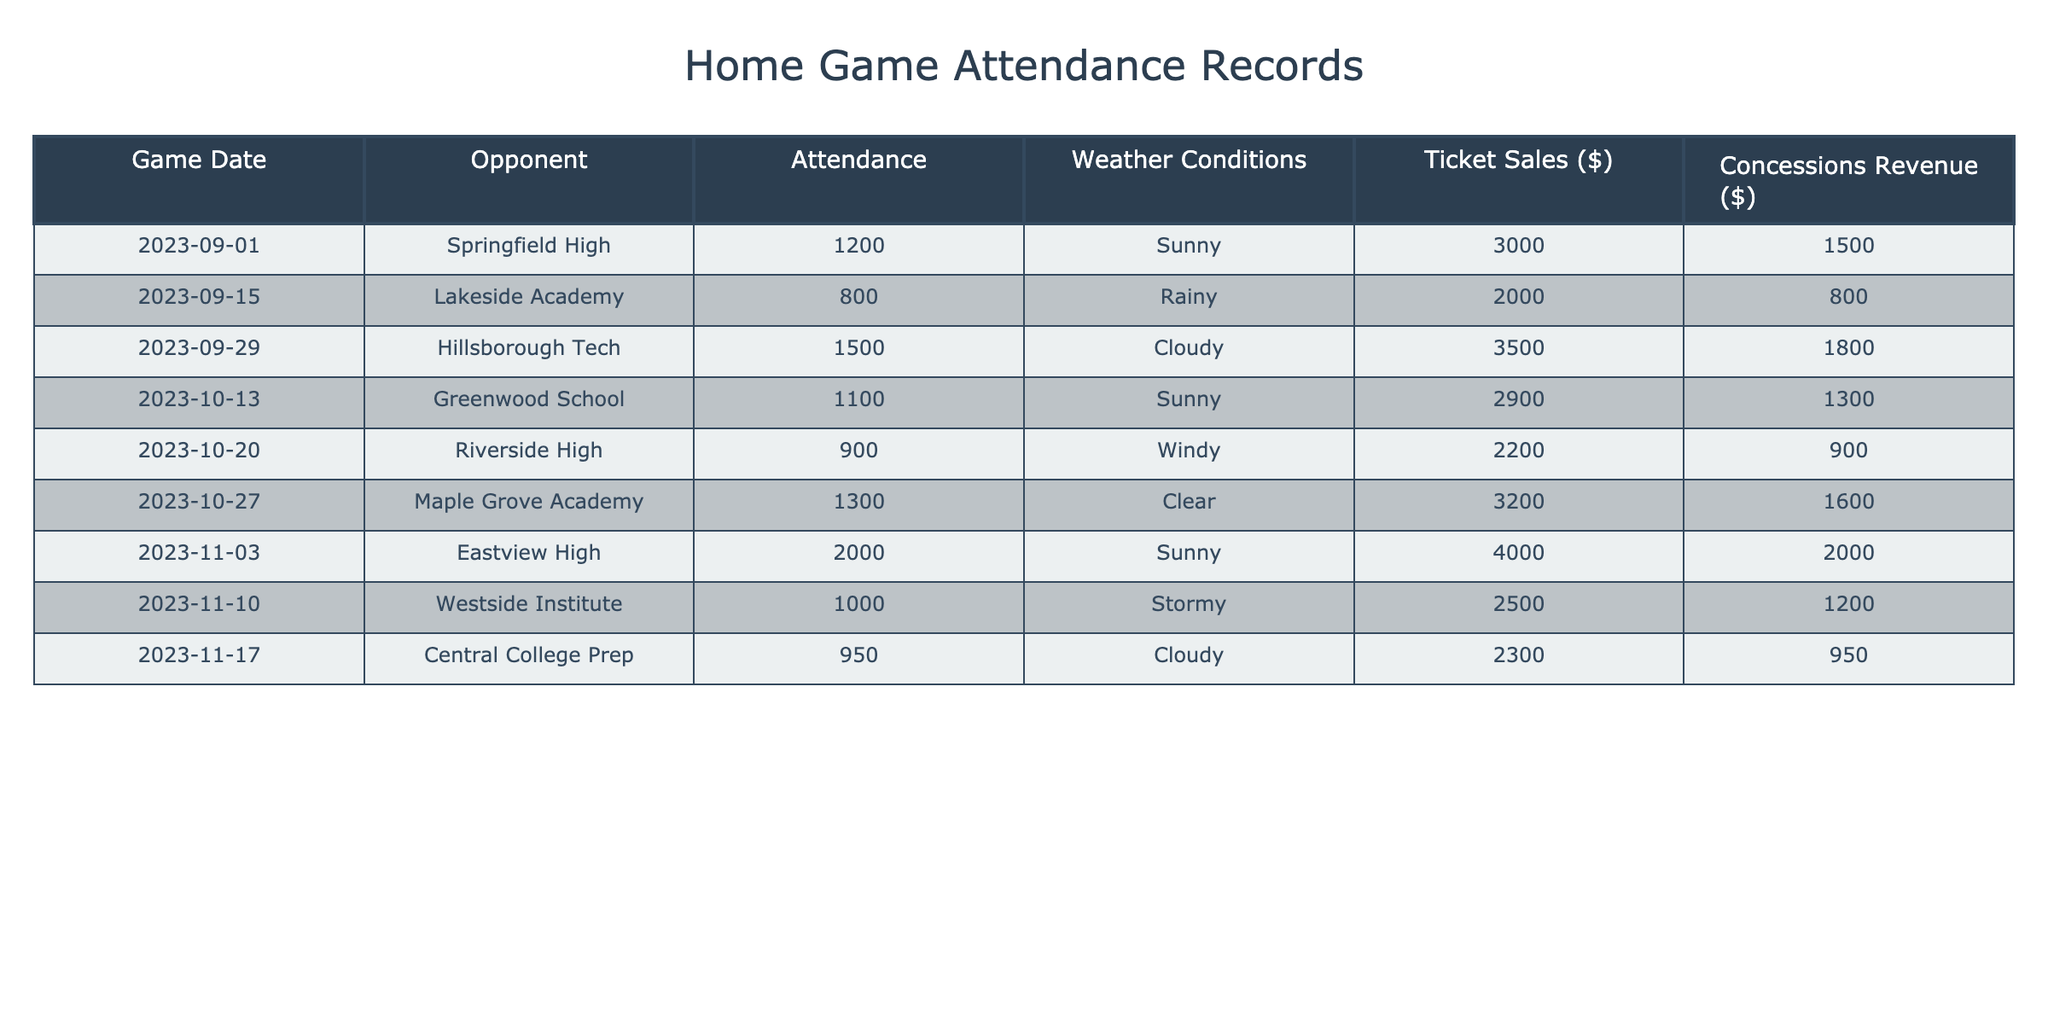What was the attendance for the game against Eastview High? The attendance for the game against Eastview High on November 3, 2023, is listed directly in the table under the Attendance column. It shows 2000.
Answer: 2000 Which game had the highest concessions revenue? To determine the highest concessions revenue, we look at the Concessions Revenue column and find the maximum value. The game against Eastview High on November 3, 2023, shows the highest revenue of 2000.
Answer: 2000 What was the average attendance across all home games? The total attendance for all games is the sum of the Attendance column: 1200 + 800 + 1500 + 1100 + 900 + 1300 + 2000 + 1000 + 950 = 10000. There are 9 games, so the average is 10000 / 9 ≈ 1111.11.
Answer: Approximately 1111 Did any game take place under rainy weather conditions? Looking at the Weather Conditions column, we see that the game on September 15, 2023, against Lakeside Academy was labeled as Rainy.
Answer: Yes Which opponent's game had the lowest ticket sales? Checking the Ticket Sales column, we scroll down to find that the game against Lakeside Academy on September 15, 2023, had ticket sales of 2000, which is the lowest compared to other games.
Answer: 2000 How much more did concessions revenue from the game against Maple Grove Academy exceed that of Riverside High? For Maple Grove Academy, the concessions revenue was 1600, while for Riverside High, it was 900. The difference is calculated as 1600 - 900 = 700.
Answer: 700 How many games had an attendance of over 1300? By examining the Attendance column, we see that the games against Hillsborough Tech (1500) and Eastview High (2000) had attendances above 1300. Thus, there are 2 games.
Answer: 2 What is the total ticket sales from all home games? We look at the Ticket Sales column and sum all the values: 3000 + 2000 + 3500 + 2900 + 2200 + 3200 + 4000 + 2500 + 2300 = 22600.
Answer: 22600 Which weather condition was present during the game with the second highest attendance? The game with the second highest attendance (1500) was against Hillsborough Tech. According to the Weather Conditions column, this game had cloudy weather, identified by looking up its respective row.
Answer: Cloudy 